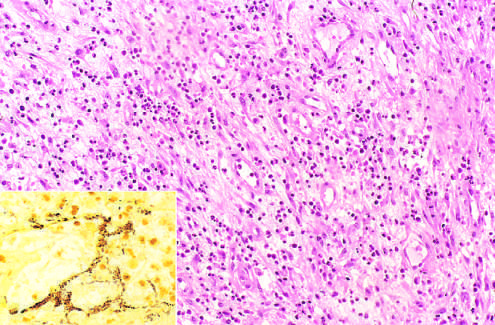what are those of acute inflammation and capillary proliferation?
Answer the question using a single word or phrase. Histologic features 